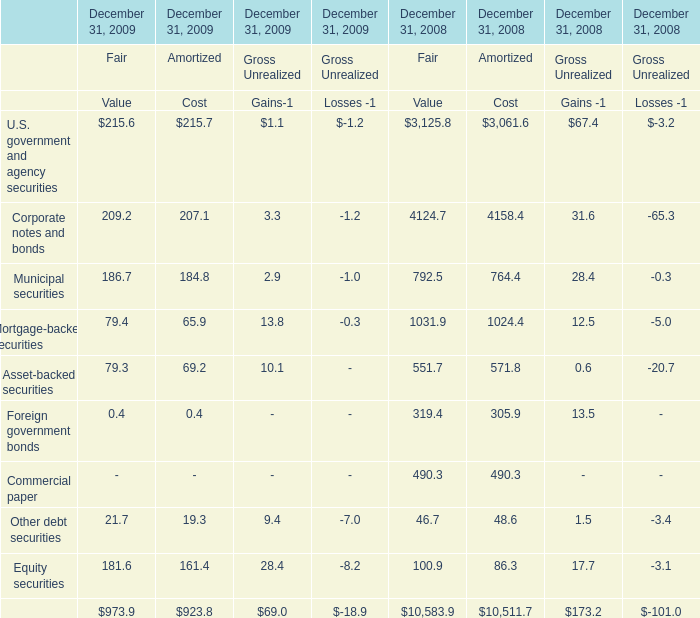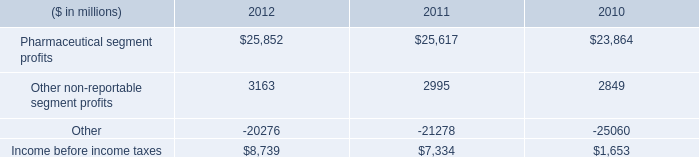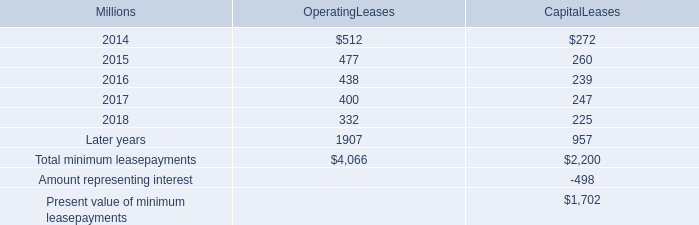what was the percentage change in rent expense for operating leases with terms exceeding one month from 2011 to 2012? 
Computations: ((631 - 637) / 637)
Answer: -0.00942. 